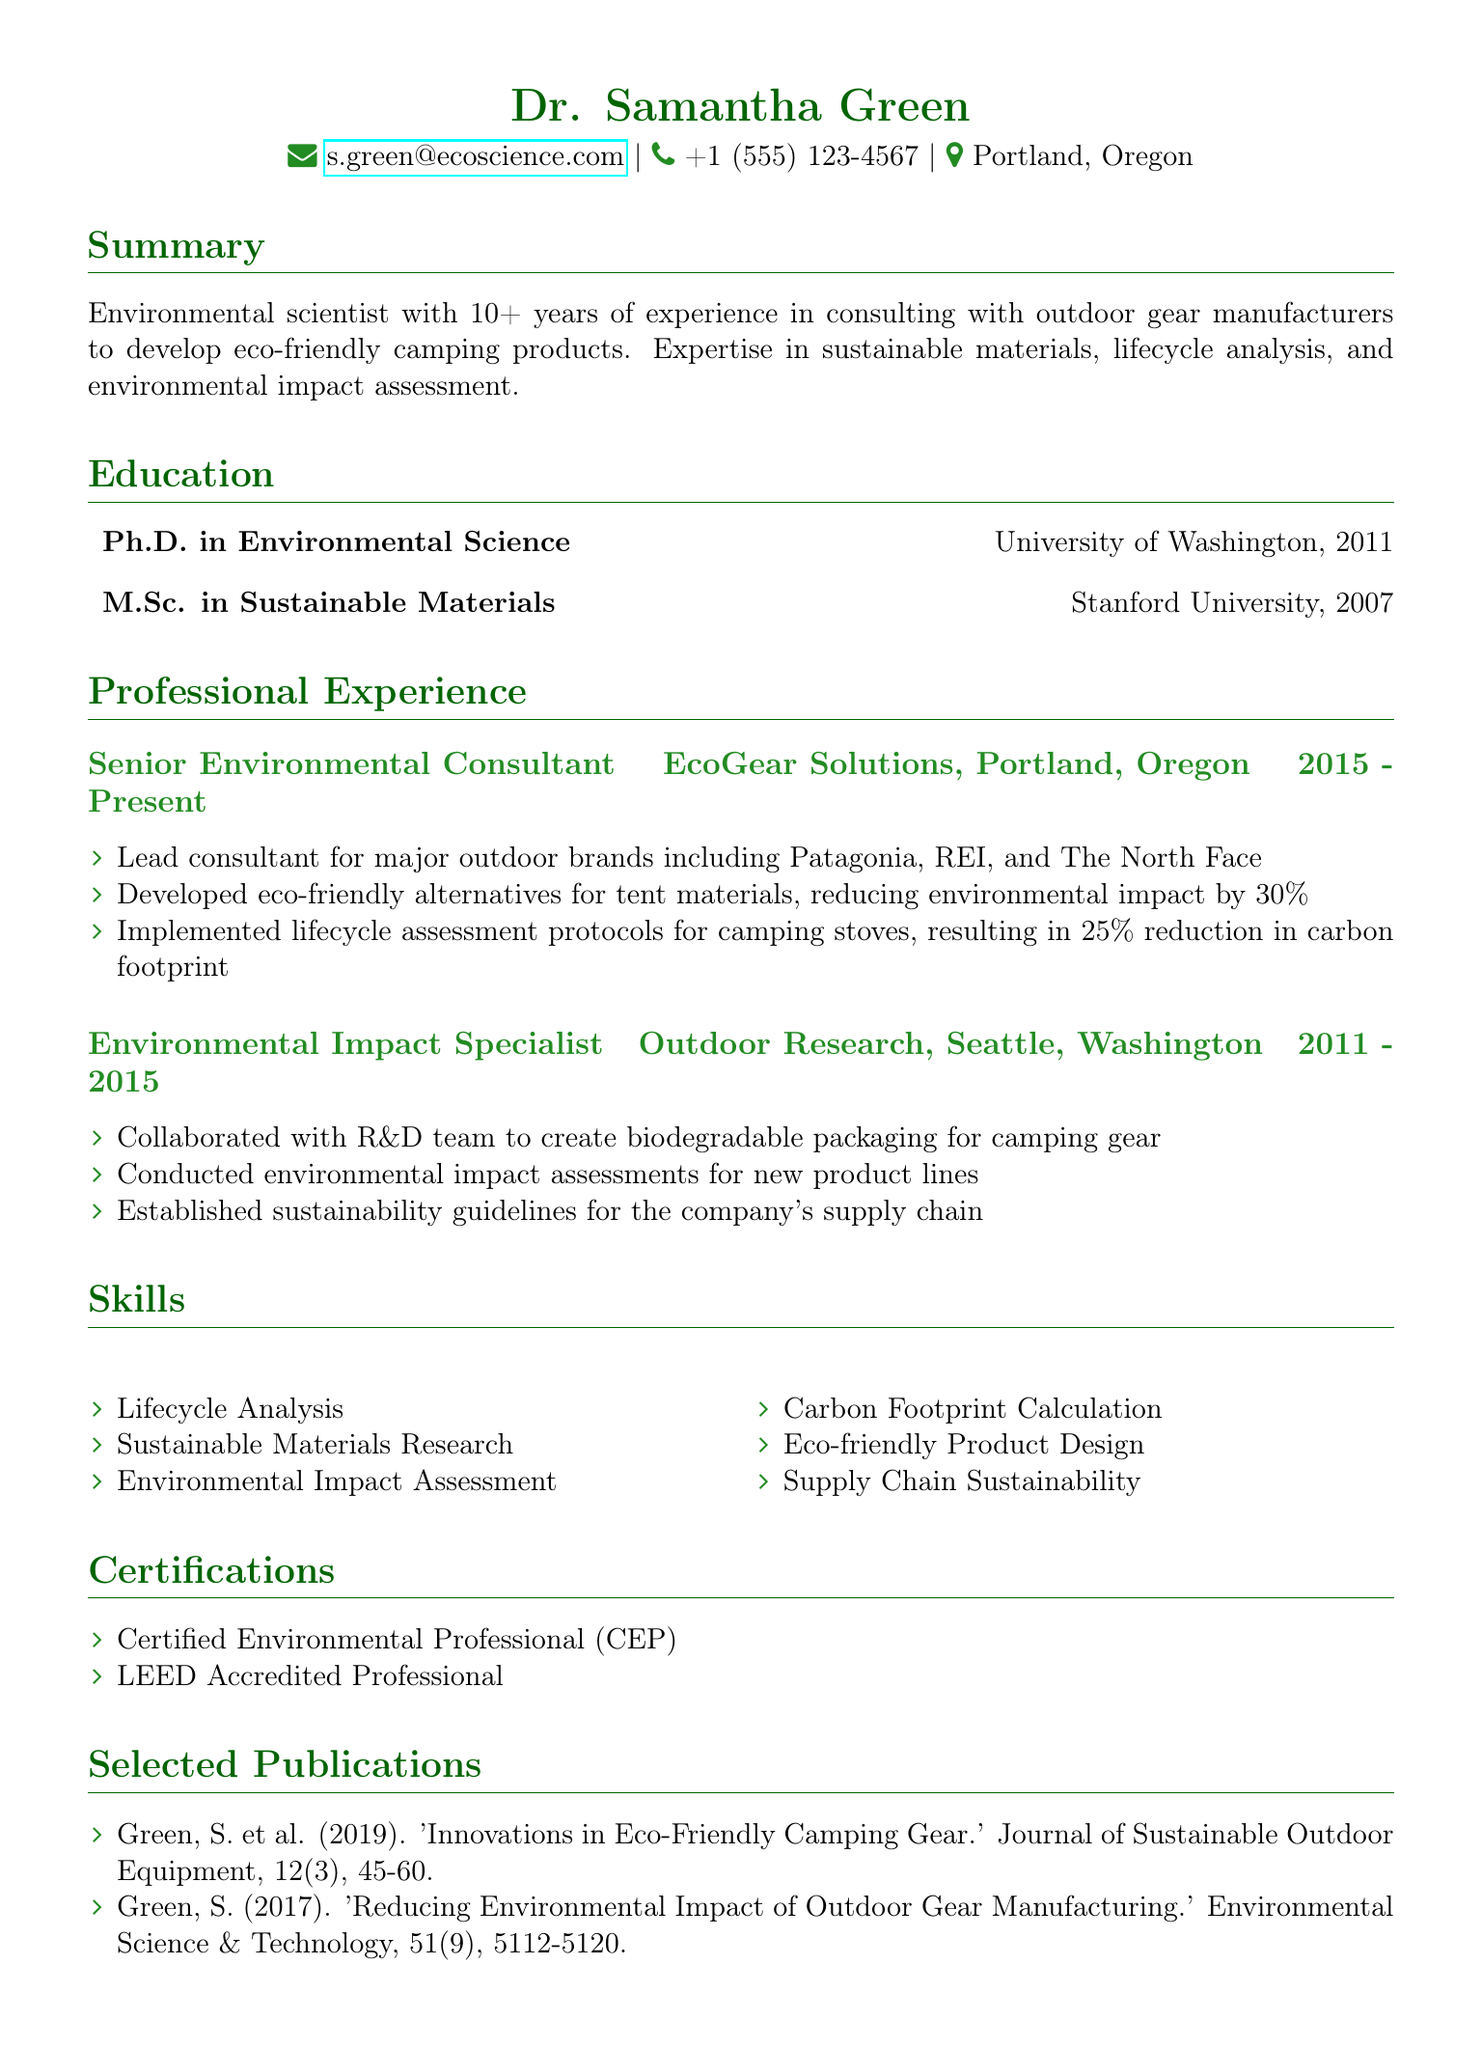What is the name of the individual? The document states the individual's name as listed at the top.
Answer: Dr. Samantha Green What is the degree obtained from Stanford University? The document provides educational details, including degrees earned and their institutions.
Answer: M.Sc. in Sustainable Materials What is the current position held by Dr. Samantha Green? The professional experience section outlines Dr. Green's current job title.
Answer: Senior Environmental Consultant In which year did Dr. Green complete her Ph.D.? The education section specifies the year of completion for Dr. Green's Ph.D.
Answer: 2011 How many years of experience does Dr. Green have in consulting with outdoor gear manufacturers? The summary mentions the total years of experience Dr. Green has.
Answer: 10+ What was the reduction in environmental impact achieved through eco-friendly tent materials? The responsibilities of Dr. Green as a consultant specify the percentage reduction achieved.
Answer: 30% Which company did Dr. Green work for prior to EcoGear Solutions? The professional experience section lists companies worked for in chronological order.
Answer: Outdoor Research What certification indicates that Dr. Green is a certified environmental professional? The certifications section lists the professional certifications earned by Dr. Green.
Answer: Certified Environmental Professional (CEP) How many publications are listed in the document? The selected publications section provides the number of publications authored by Dr. Green.
Answer: 2 